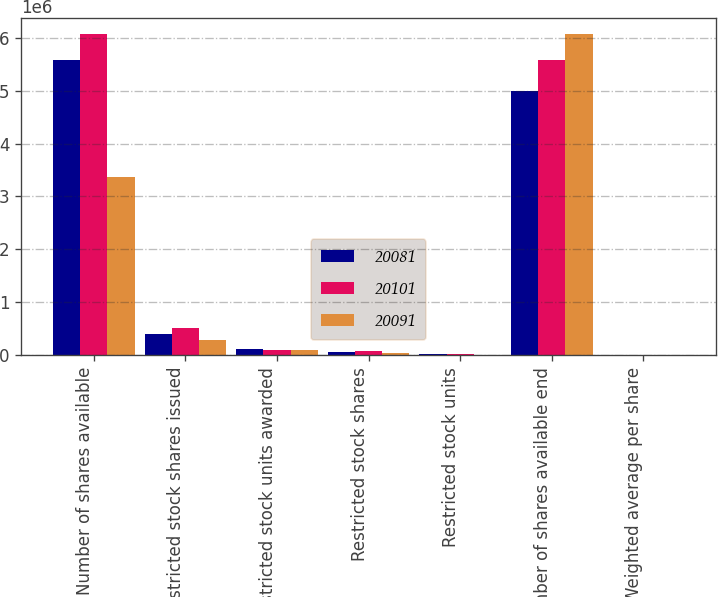Convert chart. <chart><loc_0><loc_0><loc_500><loc_500><stacked_bar_chart><ecel><fcel>Number of shares available<fcel>Restricted stock shares issued<fcel>Restricted stock units awarded<fcel>Restricted stock shares<fcel>Restricted stock units<fcel>Number of shares available end<fcel>Weighted average per share<nl><fcel>20081<fcel>5.578e+06<fcel>403360<fcel>115150<fcel>53393<fcel>12500<fcel>4.9973e+06<fcel>21.46<nl><fcel>20101<fcel>6.0786e+06<fcel>516650<fcel>106200<fcel>78788<fcel>19700<fcel>5.578e+06<fcel>16.33<nl><fcel>20091<fcel>3.365e+06<fcel>287200<fcel>96200<fcel>47977<fcel>6800<fcel>6.0786e+06<fcel>23.28<nl></chart> 